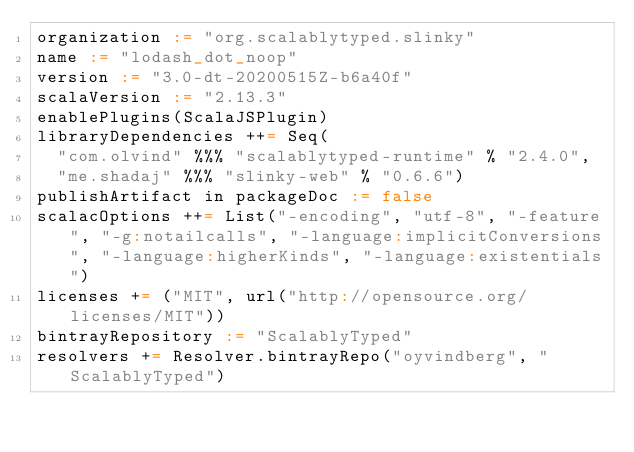<code> <loc_0><loc_0><loc_500><loc_500><_Scala_>organization := "org.scalablytyped.slinky"
name := "lodash_dot_noop"
version := "3.0-dt-20200515Z-b6a40f"
scalaVersion := "2.13.3"
enablePlugins(ScalaJSPlugin)
libraryDependencies ++= Seq(
  "com.olvind" %%% "scalablytyped-runtime" % "2.4.0",
  "me.shadaj" %%% "slinky-web" % "0.6.6")
publishArtifact in packageDoc := false
scalacOptions ++= List("-encoding", "utf-8", "-feature", "-g:notailcalls", "-language:implicitConversions", "-language:higherKinds", "-language:existentials")
licenses += ("MIT", url("http://opensource.org/licenses/MIT"))
bintrayRepository := "ScalablyTyped"
resolvers += Resolver.bintrayRepo("oyvindberg", "ScalablyTyped")
</code> 